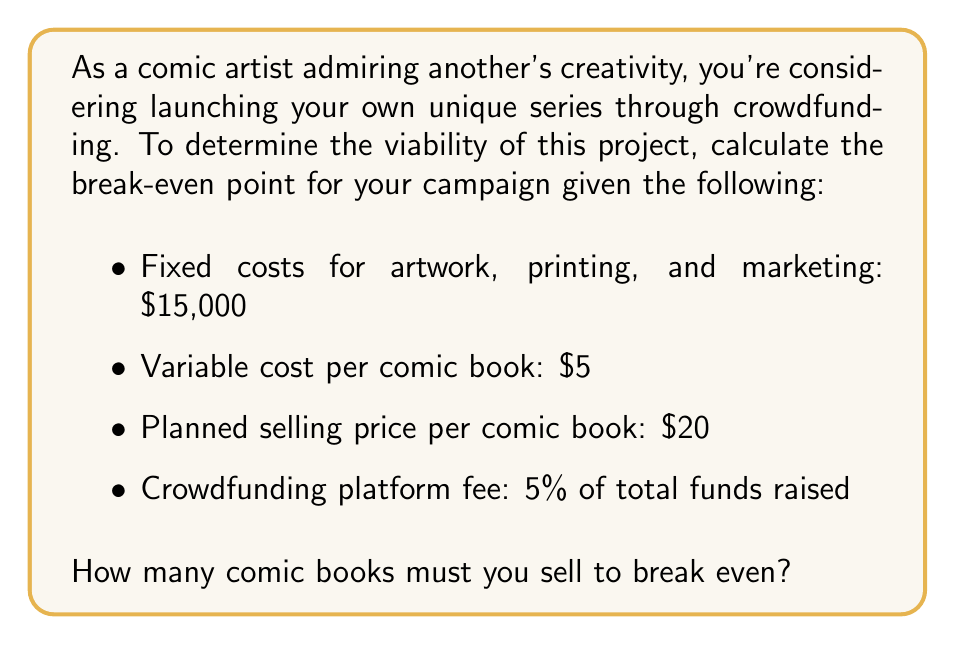Provide a solution to this math problem. To solve this problem, we need to find the point where total revenue equals total costs. Let's break it down step-by-step:

1. Define variables:
   Let $x$ be the number of comic books sold.

2. Express total revenue:
   Revenue per book = $20
   Total revenue = $20x$

3. Express total costs:
   Fixed costs = $15,000
   Variable costs = $5x$
   Platform fee = 5% of total revenue = $0.05(20x) = $1x$
   Total costs = $15,000 + 5x + 1x = $15,000 + 6x$

4. Set up the break-even equation:
   Total Revenue = Total Costs
   $20x = 15,000 + 6x$

5. Solve for $x$:
   $20x - 6x = 15,000$
   $14x = 15,000$
   $x = \frac{15,000}{14} = 1,071.43$

6. Round up to the nearest whole number:
   $x = 1,072$ comic books

Therefore, you need to sell 1,072 comic books to break even.

To verify:
Revenue: $1,072 \times $20 = $21,440$
Costs: $15,000 + (1,072 \times $5) + (5% \times $21,440) = $21,432$

The slight difference ($8) is due to rounding up to the nearest whole comic book.
Answer: 1,072 comic books 